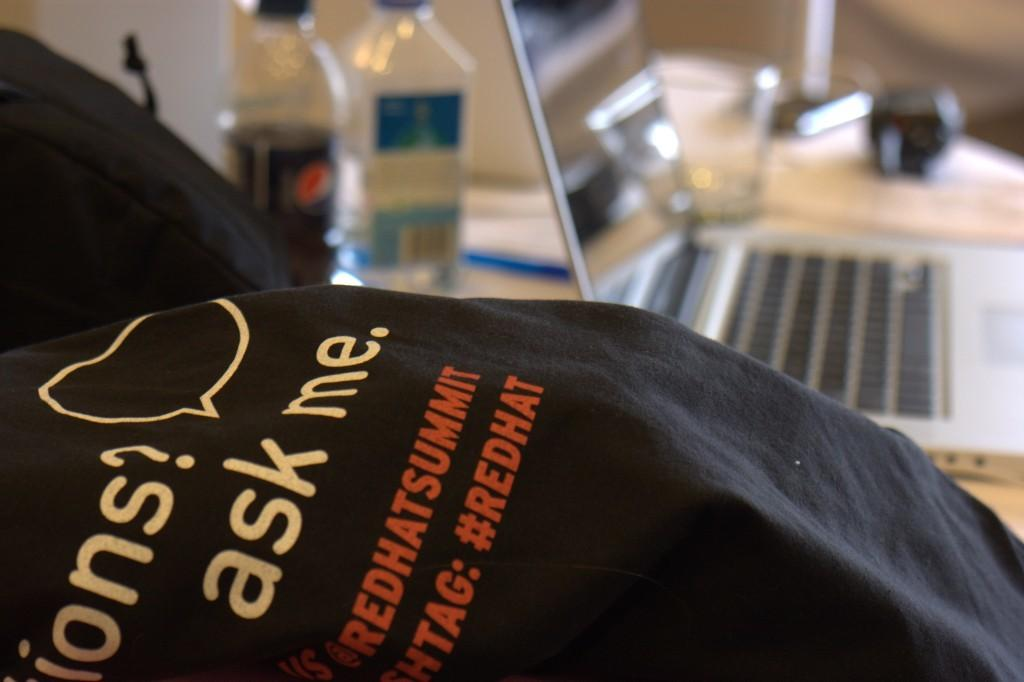What electronic device is visible in the image? There is a laptop in the image. What else can be seen on the table in the image? There are two bottles on the table in the image. Where are the laptop and bottles located? The laptop and bottles are on a table. What type of birth is depicted in the image? There is no birth depicted in the image; it features a laptop and two bottles on a table. Are there any slaves present in the image? There is no mention of slaves or any related context in the image. 